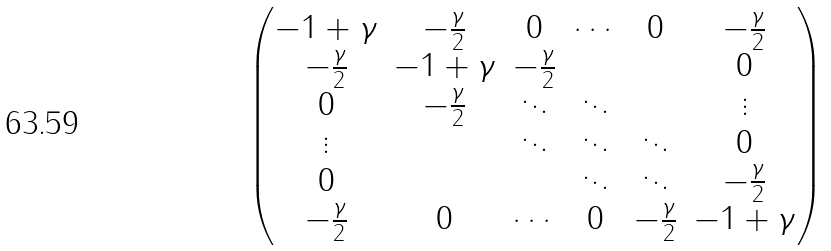Convert formula to latex. <formula><loc_0><loc_0><loc_500><loc_500>\begin{pmatrix} - 1 + \gamma & - \frac { \gamma } { 2 } & 0 & \cdots & 0 & - \frac { \gamma } { 2 } \\ - \frac { \gamma } { 2 } & - 1 + \gamma & - \frac { \gamma } { 2 } & & & 0 \\ 0 & - \frac { \gamma } { 2 } & \ddots & \ddots & & \vdots \\ \vdots & & \ddots & \ddots & \ddots & 0 \\ 0 & & & \ddots & \ddots & - \frac { \gamma } { 2 } \\ - \frac { \gamma } { 2 } & 0 & \cdots & 0 & - \frac { \gamma } { 2 } & - 1 + \gamma \end{pmatrix}</formula> 